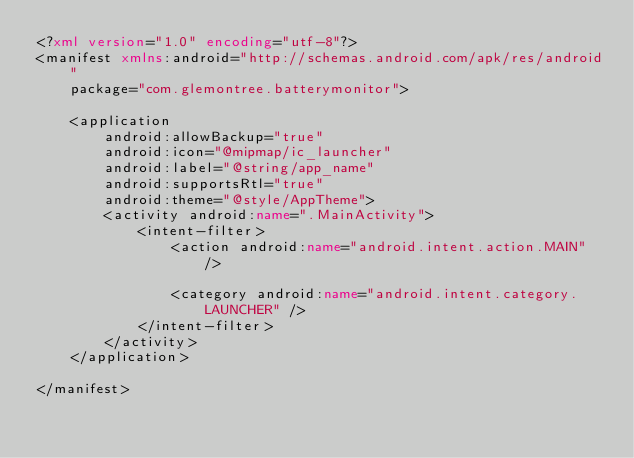Convert code to text. <code><loc_0><loc_0><loc_500><loc_500><_XML_><?xml version="1.0" encoding="utf-8"?>
<manifest xmlns:android="http://schemas.android.com/apk/res/android"
    package="com.glemontree.batterymonitor">

    <application
        android:allowBackup="true"
        android:icon="@mipmap/ic_launcher"
        android:label="@string/app_name"
        android:supportsRtl="true"
        android:theme="@style/AppTheme">
        <activity android:name=".MainActivity">
            <intent-filter>
                <action android:name="android.intent.action.MAIN" />

                <category android:name="android.intent.category.LAUNCHER" />
            </intent-filter>
        </activity>
    </application>

</manifest></code> 